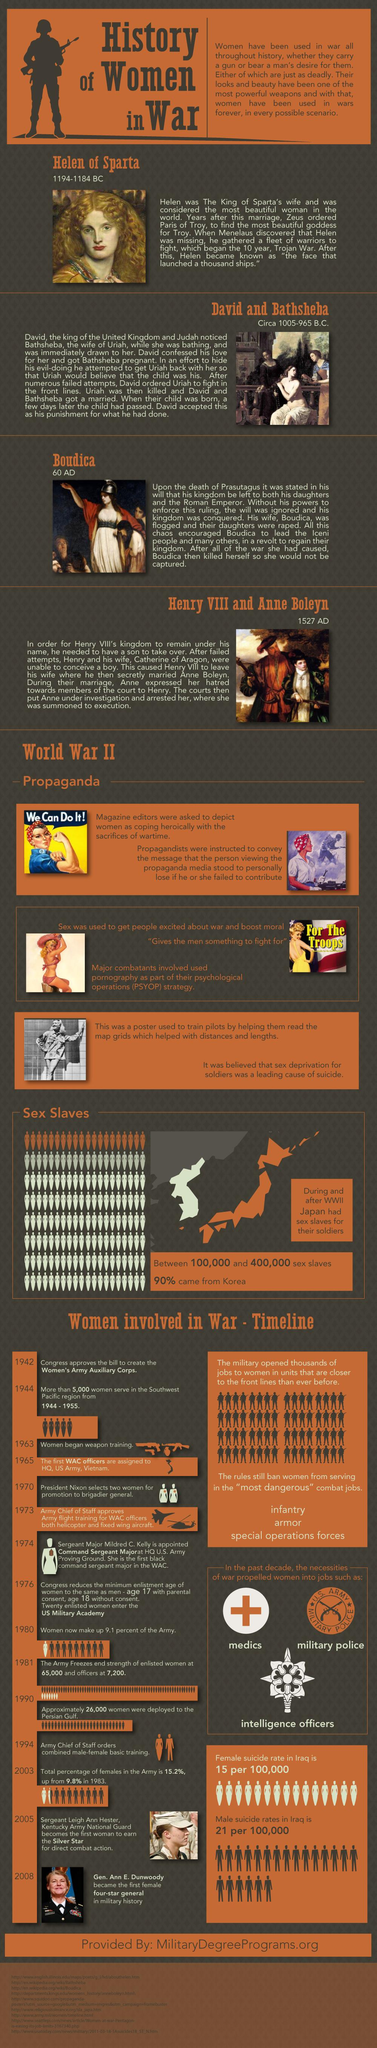Indicate a few pertinent items in this graphic. The suicide rate is higher among men in Iraq than among women. Helen of Sparta died in 1184 BC. The third section of this infographic features Boudica. The second section of this infographic features David and Bathsheba. Henry VIII and Anne Boleyn are featured in the fourth section of this infographic. 